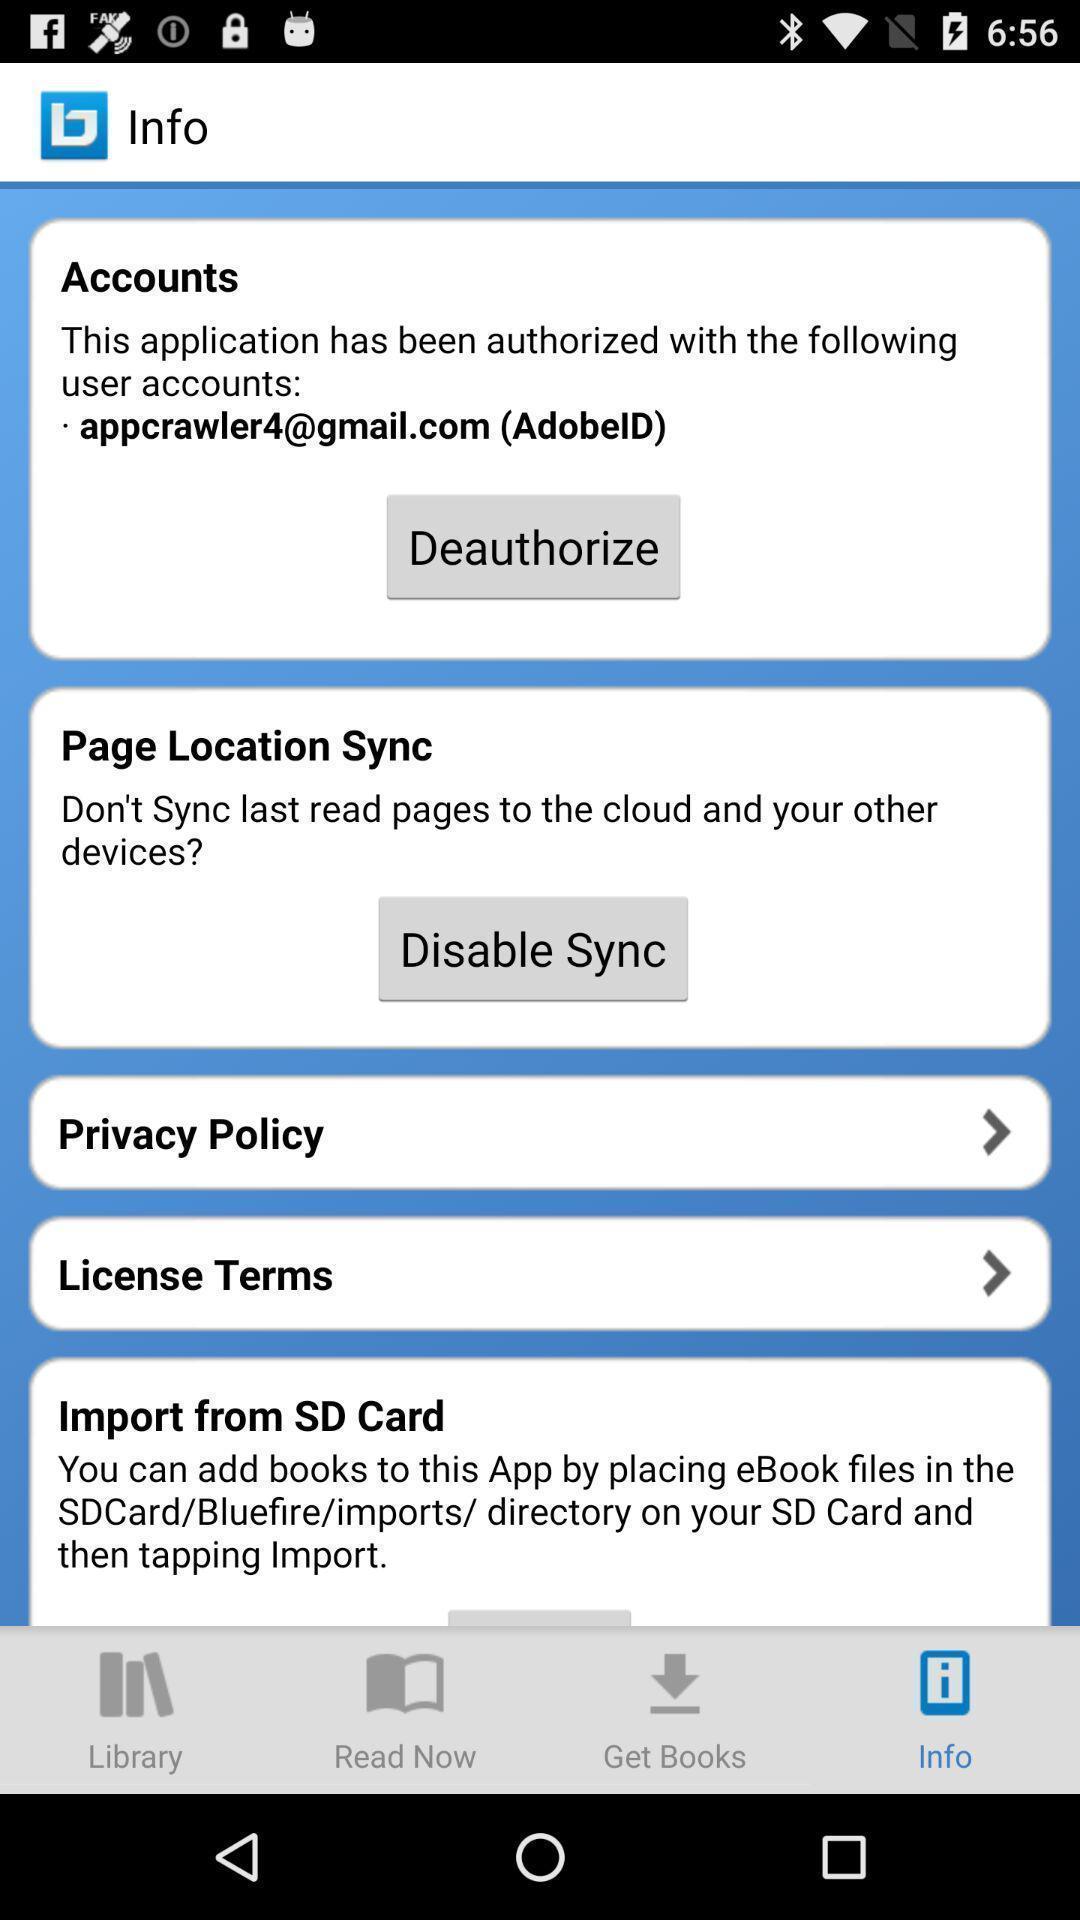What details can you identify in this image? Page that displaying application info. 